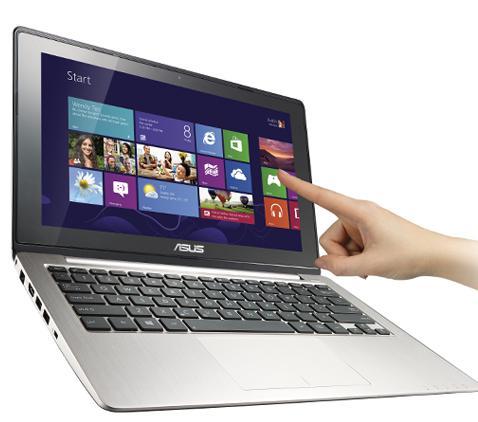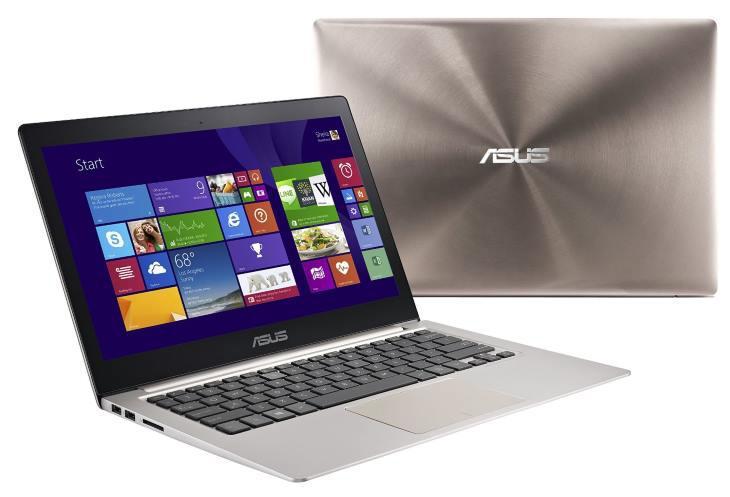The first image is the image on the left, the second image is the image on the right. Assess this claim about the two images: "A finger is pointing to an open laptop screen displaying a grid of rectangles and squares in the left image.". Correct or not? Answer yes or no. Yes. The first image is the image on the left, the second image is the image on the right. For the images displayed, is the sentence "There are two computers in total." factually correct? Answer yes or no. No. 